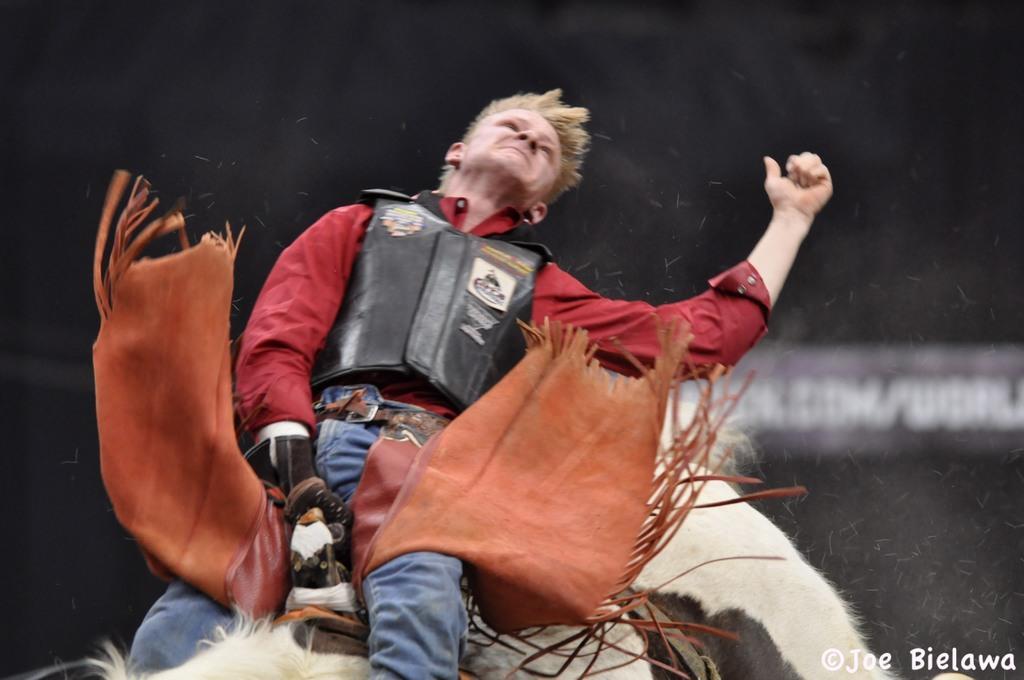Please provide a concise description of this image. In this image I can see the person sitting on an animal. I can see an animal is in cream and black color. The person is wearing the black, red and blue color dress. And there is a black background. 